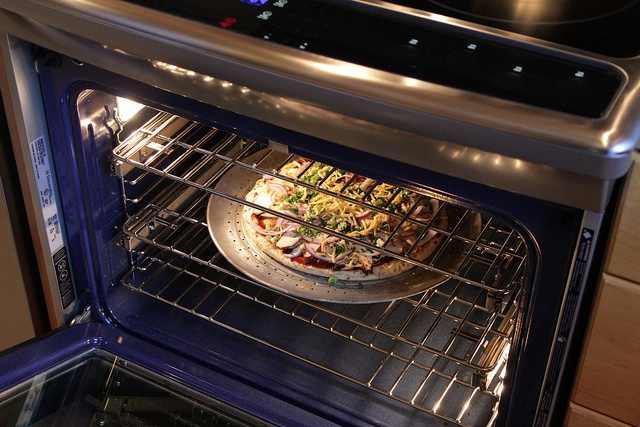Describe the objects in this image and their specific colors. I can see oven in black, maroon, and gray tones and pizza in maroon, black, tan, and olive tones in this image. 